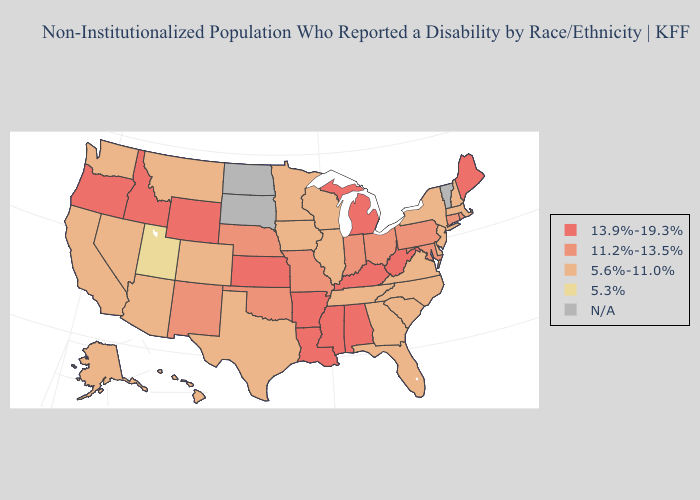Does Utah have the lowest value in the USA?
Give a very brief answer. Yes. What is the lowest value in the South?
Short answer required. 5.6%-11.0%. What is the lowest value in the Northeast?
Answer briefly. 5.6%-11.0%. What is the lowest value in states that border Mississippi?
Keep it brief. 5.6%-11.0%. What is the highest value in states that border Ohio?
Give a very brief answer. 13.9%-19.3%. Does Colorado have the lowest value in the West?
Concise answer only. No. Name the states that have a value in the range 13.9%-19.3%?
Be succinct. Alabama, Arkansas, Idaho, Kansas, Kentucky, Louisiana, Maine, Michigan, Mississippi, Oregon, West Virginia, Wyoming. Name the states that have a value in the range 13.9%-19.3%?
Answer briefly. Alabama, Arkansas, Idaho, Kansas, Kentucky, Louisiana, Maine, Michigan, Mississippi, Oregon, West Virginia, Wyoming. Name the states that have a value in the range N/A?
Answer briefly. North Dakota, South Dakota, Vermont. Name the states that have a value in the range 13.9%-19.3%?
Give a very brief answer. Alabama, Arkansas, Idaho, Kansas, Kentucky, Louisiana, Maine, Michigan, Mississippi, Oregon, West Virginia, Wyoming. Name the states that have a value in the range N/A?
Write a very short answer. North Dakota, South Dakota, Vermont. Which states have the highest value in the USA?
Answer briefly. Alabama, Arkansas, Idaho, Kansas, Kentucky, Louisiana, Maine, Michigan, Mississippi, Oregon, West Virginia, Wyoming. What is the lowest value in the USA?
Give a very brief answer. 5.3%. Does Alabama have the lowest value in the South?
Short answer required. No. 